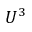<formula> <loc_0><loc_0><loc_500><loc_500>U ^ { 3 }</formula> 